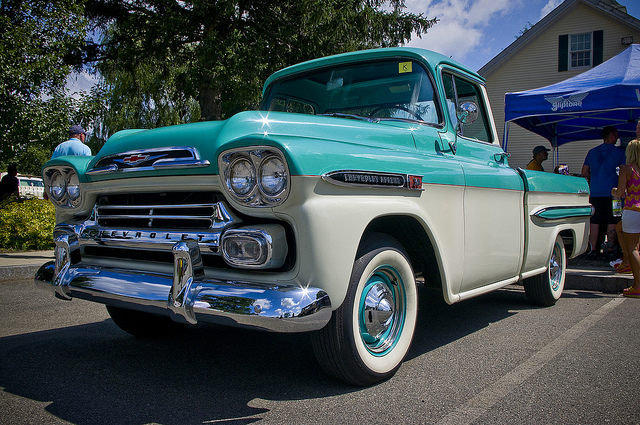What type of vehicle is shown? The vehicle shown in the image is a classic car, specifically a vintage Chevrolet truck. Its distinct features, such as the front grille design and two-tone paint job, are characteristic of the 1950s Chevrolet trucks. 